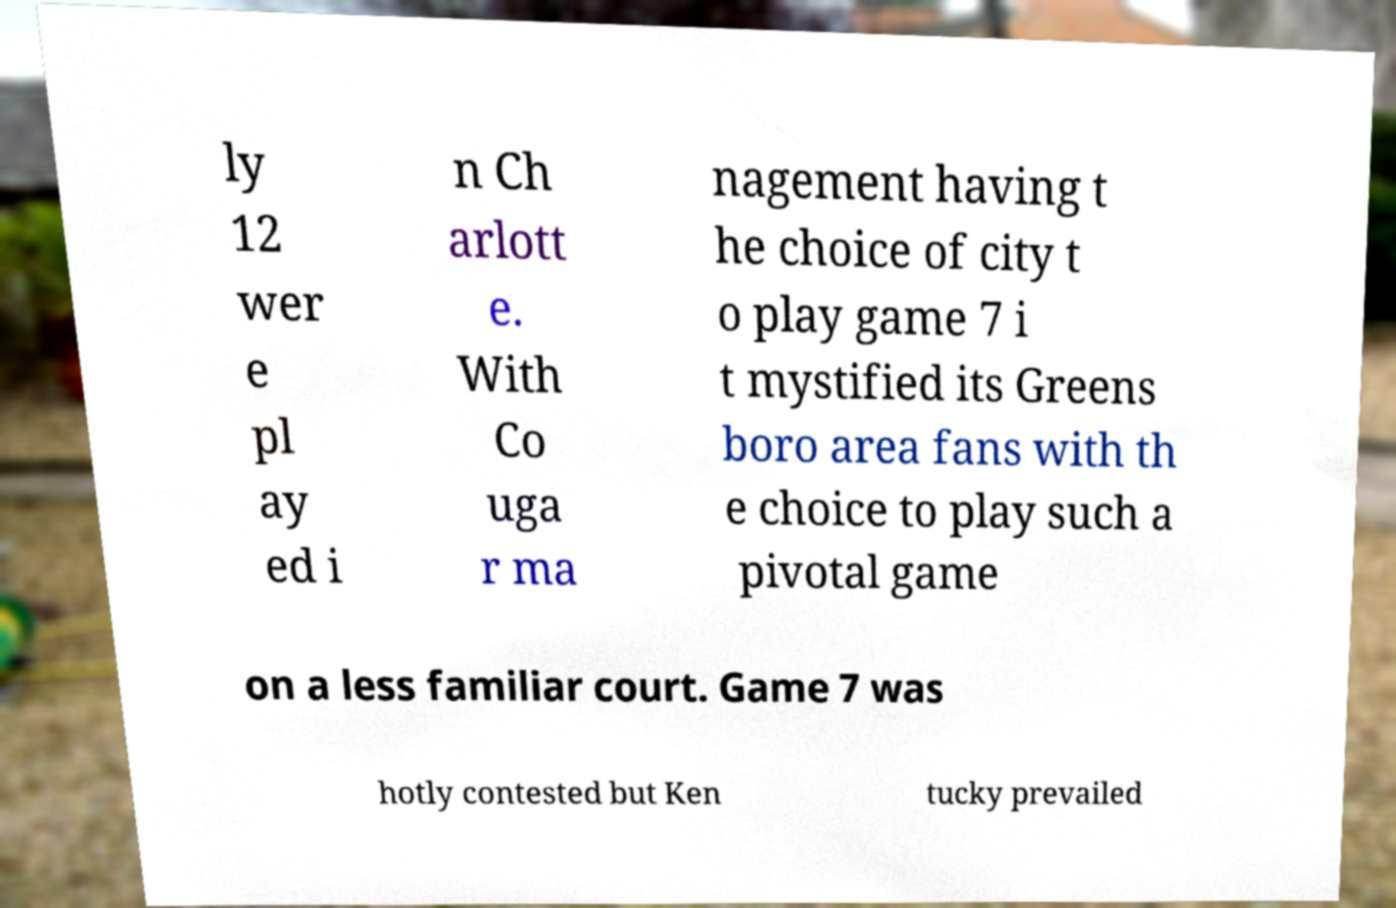What messages or text are displayed in this image? I need them in a readable, typed format. ly 12 wer e pl ay ed i n Ch arlott e. With Co uga r ma nagement having t he choice of city t o play game 7 i t mystified its Greens boro area fans with th e choice to play such a pivotal game on a less familiar court. Game 7 was hotly contested but Ken tucky prevailed 